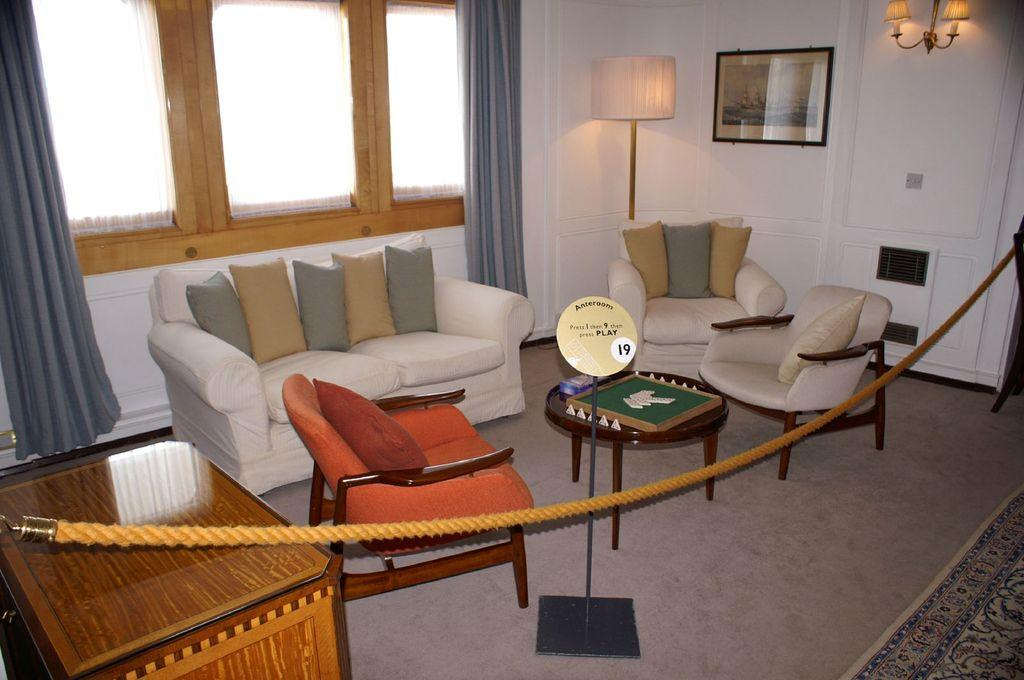What color is the rope that is visible in the image? The rope in the image is yellow. What piece of furniture is behind the yellow rope? There is a sofa behind the yellow rope. What is located behind the sofa? There is a stool behind the sofa. What can be seen behind the stool? There are windows with grey curtains behind the stool. What object is at the right side of the image? There is a photo frame at the right side of the image. What type of lighting is present in the image? There is a lamp in the image. How much money is being exchanged in the image? There is no exchange of money depicted in the image. What type of authority figure is present in the image? There is no authority figure present in the image. 